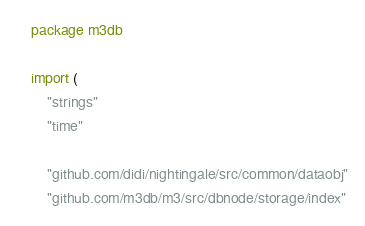<code> <loc_0><loc_0><loc_500><loc_500><_Go_>package m3db

import (
	"strings"
	"time"

	"github.com/didi/nightingale/src/common/dataobj"
	"github.com/m3db/m3/src/dbnode/storage/index"</code> 